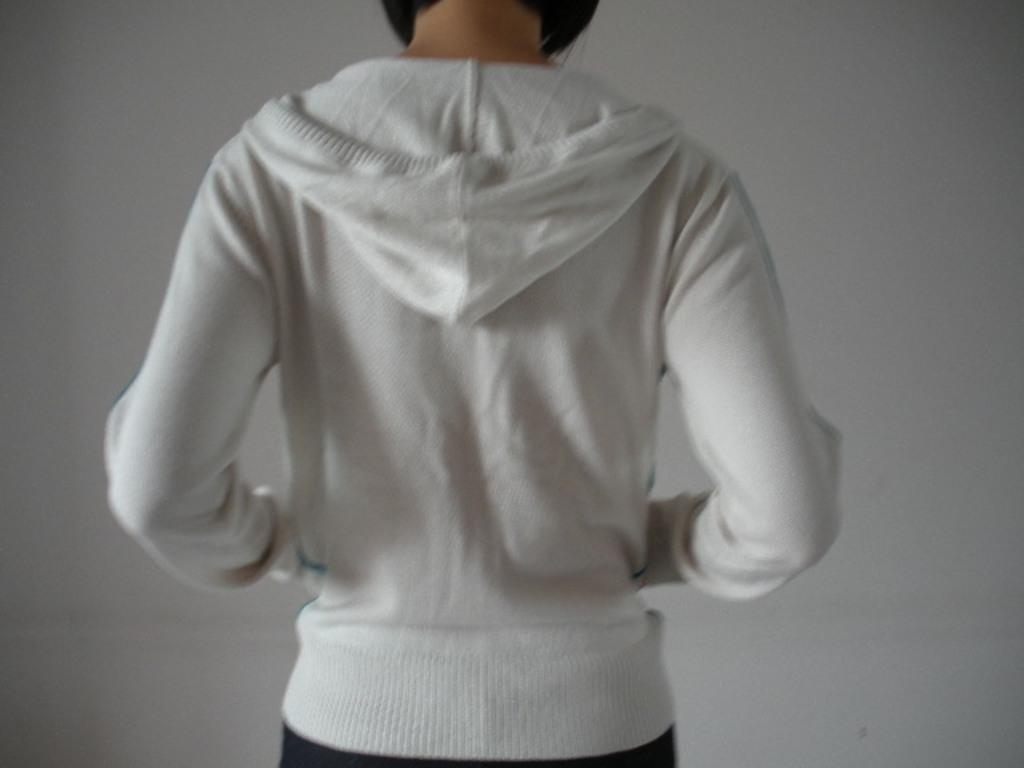What is the main subject of the image? There is a person in the image. What is the person wearing? The person is wearing a white jacket. What direction is the person facing? The person is standing facing the back side. What is the color of the background in the image? The background of the image is white. How many zippers can be seen on the person's white jacket in the image? There is no mention of zippers on the person's white jacket in the image, so it cannot be determined. What scientific experiment is being conducted in the image? There is no indication of a scientific experiment being conducted in the image. 